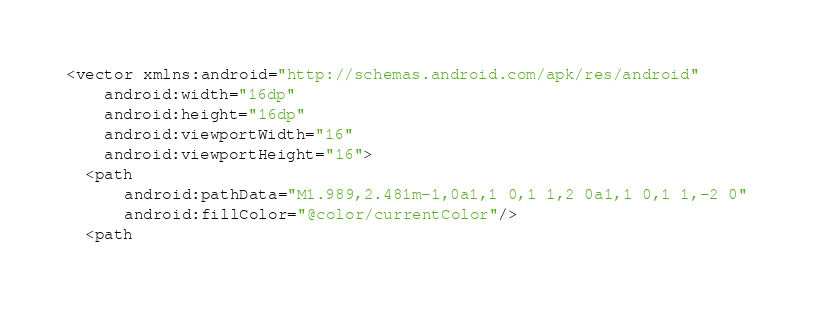<code> <loc_0><loc_0><loc_500><loc_500><_XML_><vector xmlns:android="http://schemas.android.com/apk/res/android"
    android:width="16dp"
    android:height="16dp"
    android:viewportWidth="16"
    android:viewportHeight="16">
  <path
      android:pathData="M1.989,2.481m-1,0a1,1 0,1 1,2 0a1,1 0,1 1,-2 0"
      android:fillColor="@color/currentColor"/>
  <path</code> 